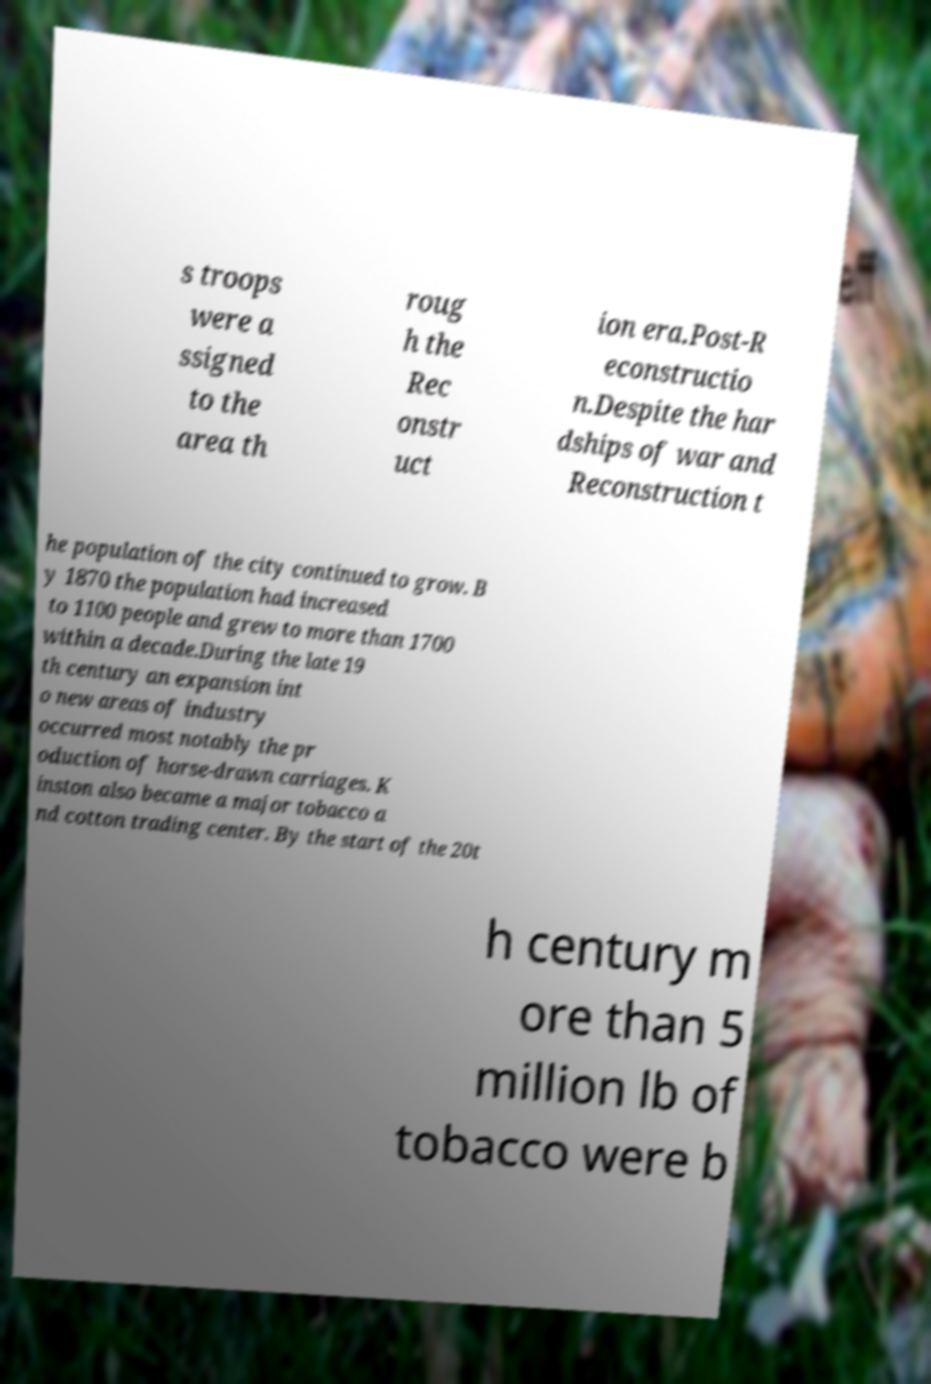Could you assist in decoding the text presented in this image and type it out clearly? s troops were a ssigned to the area th roug h the Rec onstr uct ion era.Post-R econstructio n.Despite the har dships of war and Reconstruction t he population of the city continued to grow. B y 1870 the population had increased to 1100 people and grew to more than 1700 within a decade.During the late 19 th century an expansion int o new areas of industry occurred most notably the pr oduction of horse-drawn carriages. K inston also became a major tobacco a nd cotton trading center. By the start of the 20t h century m ore than 5 million lb of tobacco were b 